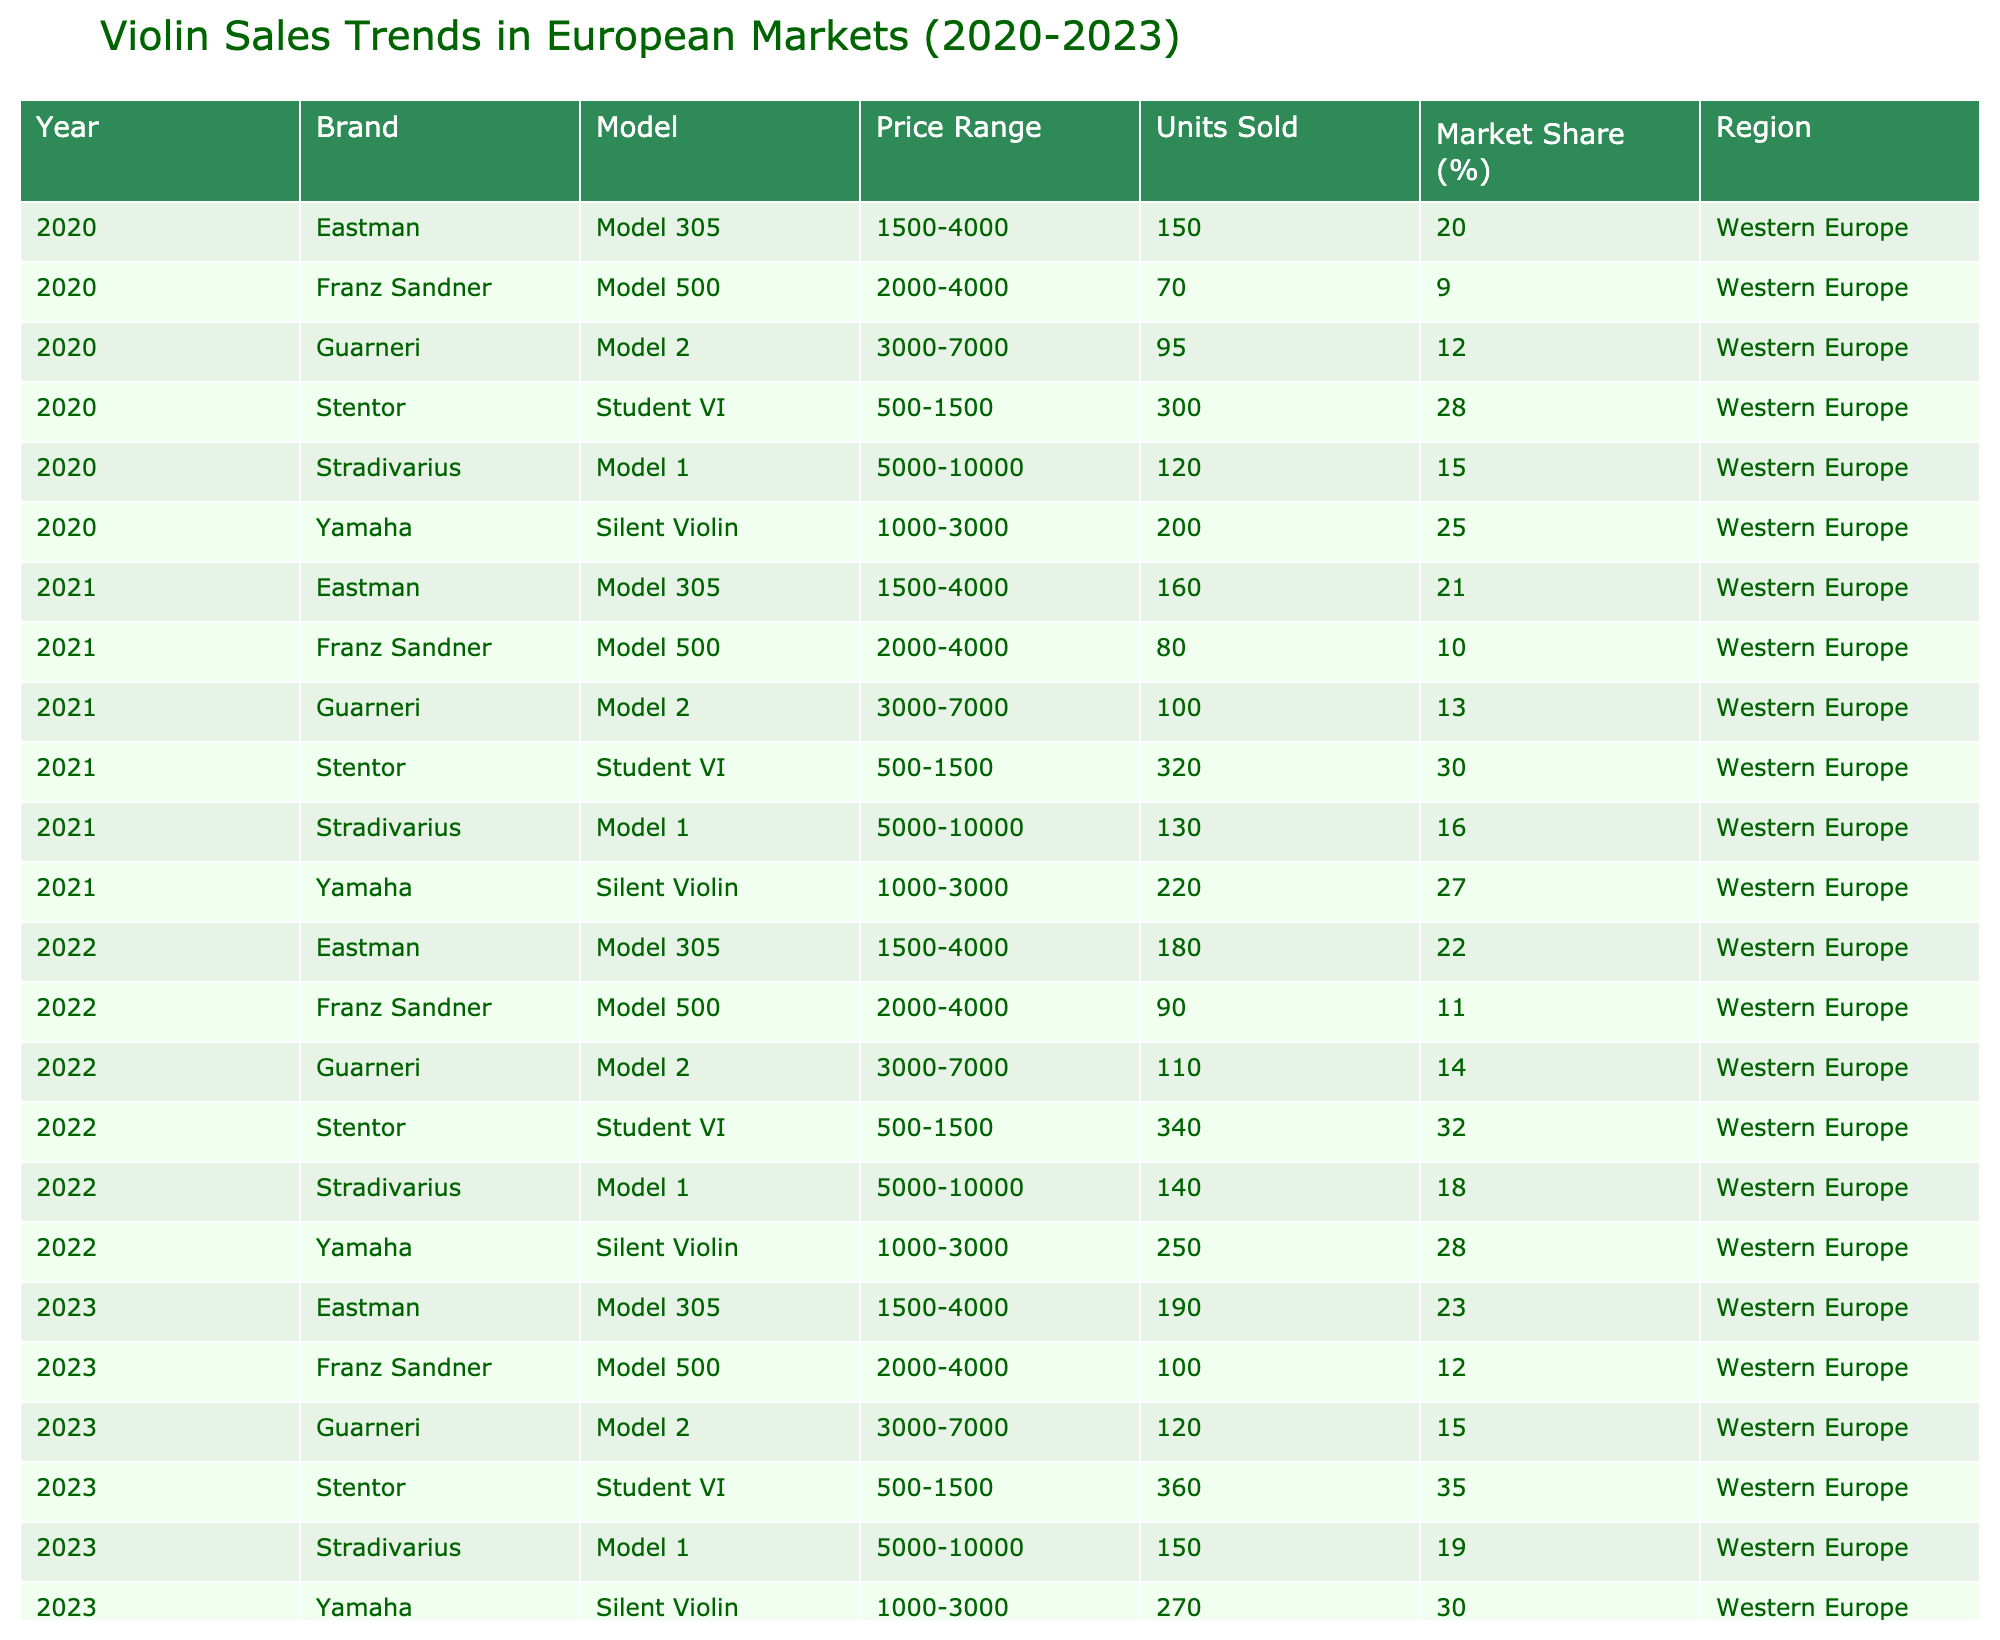What was the market share percentage of Stentor in 2023? In 2023, Stentor had a market share of 35%, as listed in the table.
Answer: 35% Which brand had the highest units sold in 2022? In 2022, Stentor sold 340 units, which is the highest among the listed brands for that year.
Answer: Stentor What is the total number of units sold by Yamaha from 2020 to 2023? The total units sold by Yamaha are 200 (2020) + 220 (2021) + 250 (2022) + 270 (2023) = 940.
Answer: 940 Did Guarneri increase or decrease in units sold from 2021 to 2022? Guarneri decreased from 100 units in 2021 to 110 units in 2022, indicating an increase in units sold.
Answer: Increase What was the average price range for the brand Stradivarius from 2020 to 2023? The price range for Stradivarius remained consistent at 5000-10000 across all years, making the average the same, 5000-10000.
Answer: 5000-10000 Which brand consistently sold more units than Franz Sandner from 2020 to 2023? Stentor consistently sold more units than Franz Sandner in all years, with totals of 300, 320, 340, and 360 against Franz Sandner's 70, 80, 90, and 100 units.
Answer: Stentor What was the percentage increase in units sold by Eastman from 2020 to 2023? Eastman sold 150 units in 2020 and 190 in 2023, calculated as ((190 - 150) / 150) * 100 = 26.67%, which rounds to approximately 27%.
Answer: 27% Which brand had the lowest market share in 2020? Franz Sandner had the lowest market share at 9% in 2020.
Answer: 9% Did Stentor have the highest sales in the 1000-3000 price range every year? Yes, Stentor had the highest sales in the 1000-3000 price range each year, reaching 300 units in 2020, 320 in 2021, 340 in 2022, and 360 in 2023.
Answer: Yes What is the trend in units sold by Guarneri from 2020 to 2023? Guarneri's units sold fluctuated but saw a general decline from 95 units in 2020 to 120 in 2023. Therefore, it can be perceived as an increase.
Answer: Increase 